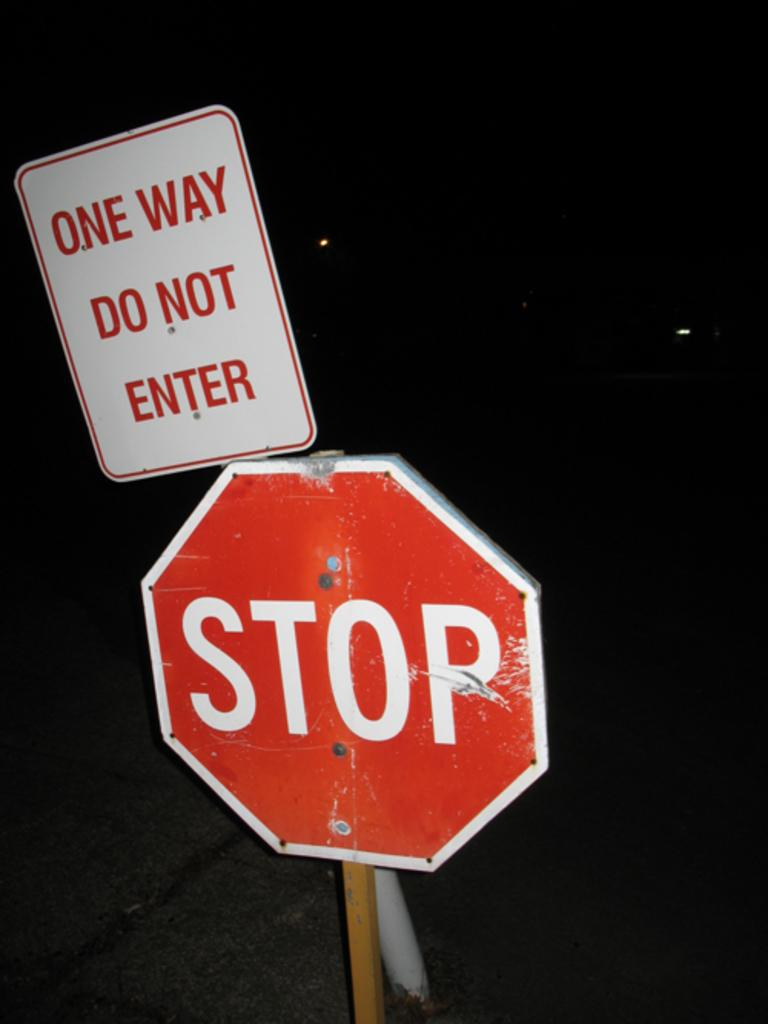<image>
Describe the image concisely. Above the stop sign, there is another sign warning not to enter because it is a one way street. 